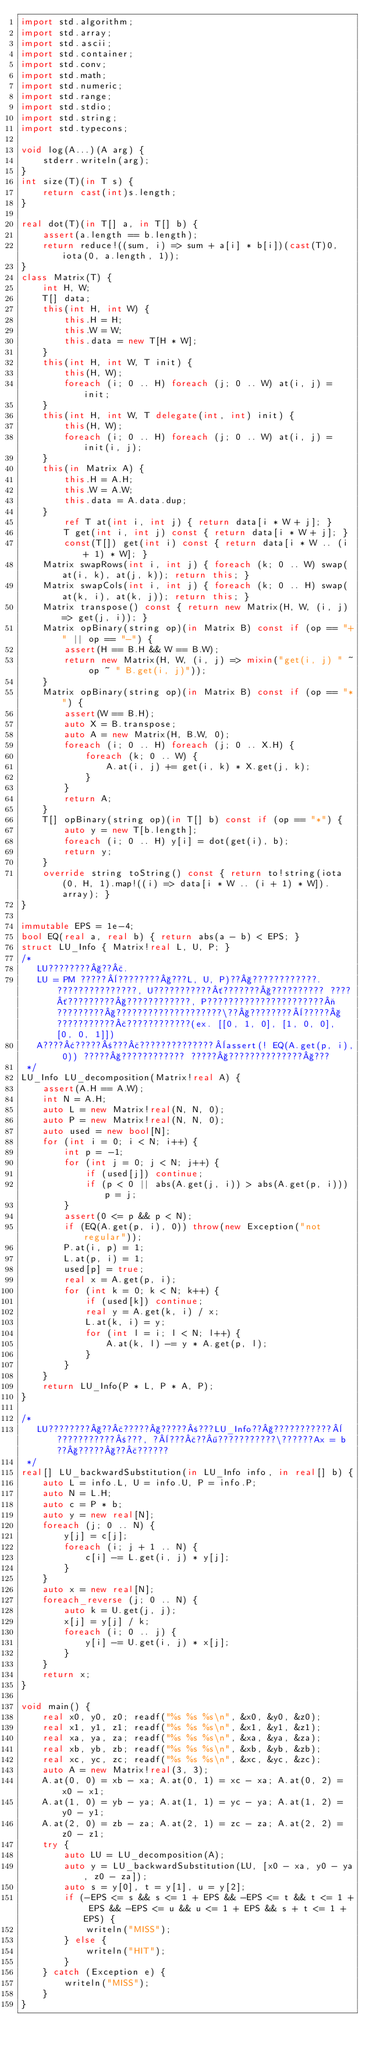<code> <loc_0><loc_0><loc_500><loc_500><_D_>import std.algorithm;
import std.array;
import std.ascii;
import std.container;
import std.conv;
import std.math;
import std.numeric;
import std.range;
import std.stdio;
import std.string;
import std.typecons;

void log(A...)(A arg) {
    stderr.writeln(arg);
}
int size(T)(in T s) {
    return cast(int)s.length;
}

real dot(T)(in T[] a, in T[] b) {
    assert(a.length == b.length);
    return reduce!((sum, i) => sum + a[i] * b[i])(cast(T)0, iota(0, a.length, 1));
}
class Matrix(T) {
    int H, W;
    T[] data;
    this(int H, int W) {
        this.H = H;
        this.W = W;
        this.data = new T[H * W];
    }
    this(int H, int W, T init) {
        this(H, W);
        foreach (i; 0 .. H) foreach (j; 0 .. W) at(i, j) = init;
    }
    this(int H, int W, T delegate(int, int) init) {
        this(H, W);
        foreach (i; 0 .. H) foreach (j; 0 .. W) at(i, j) = init(i, j);
    }
    this(in Matrix A) {
        this.H = A.H;
        this.W = A.W;
        this.data = A.data.dup;
    }
        ref T at(int i, int j) { return data[i * W + j]; }
        T get(int i, int j) const { return data[i * W + j]; }
        const(T[]) get(int i) const { return data[i * W .. (i + 1) * W]; }
    Matrix swapRows(int i, int j) { foreach (k; 0 .. W) swap(at(i, k), at(j, k)); return this; }
    Matrix swapCols(int i, int j) { foreach (k; 0 .. H) swap(at(k, i), at(k, j)); return this; }
    Matrix transpose() const { return new Matrix(H, W, (i, j) => get(j, i)); }
    Matrix opBinary(string op)(in Matrix B) const if (op == "+" || op == "-") {
        assert(H == B.H && W == B.W);
        return new Matrix(H, W, (i, j) => mixin("get(i, j) " ~ op ~ " B.get(i, j)"));
    }
    Matrix opBinary(string op)(in Matrix B) const if (op == "*") {
        assert(W == B.H);
        auto X = B.transpose;
        auto A = new Matrix(H, B.W, 0);
        foreach (i; 0 .. H) foreach (j; 0 .. X.H) {
            foreach (k; 0 .. W) {
                A.at(i, j) += get(i, k) * X.get(j, k);
            }
        }
        return A;
    }
    T[] opBinary(string op)(in T[] b) const if (op == "*") {
        auto y = new T[b.length];
        foreach (i; 0 .. H) y[i] = dot(get(i), b);
        return y;
    }
    override string toString() const { return to!string(iota(0, H, 1).map!((i) => data[i * W .. (i + 1) * W]).array); }
}

immutable EPS = 1e-4;
bool EQ(real a, real b) { return abs(a - b) < EPS; }
struct LU_Info { Matrix!real L, U, P; }
/*
   LU????????§??£.
   LU = PM ?????¨????????§???L, U, P)??§????????????. ???????????????, U???????????´???????§?????????? ????´?????????§????????????, P??????????????????????¬?????????§????????????????????\??§????????¨?????§???????????£????????????(ex. [[0, 1, 0], [1, 0, 0], [0, 0, 1]])
   A????¢?????±???£??????????????¨assert(! EQ(A.get(p, i), 0)) ?????§???????????? ?????§??????????????§???
 */
LU_Info LU_decomposition(Matrix!real A) {
    assert(A.H == A.W);
    int N = A.H;
    auto L = new Matrix!real(N, N, 0);
    auto P = new Matrix!real(N, N, 0);
    auto used = new bool[N];
    for (int i = 0; i < N; i++) {
        int p = -1;
        for (int j = 0; j < N; j++) {
            if (used[j]) continue;
            if (p < 0 || abs(A.get(j, i)) > abs(A.get(p, i))) p = j;
        }
        assert(0 <= p && p < N);
        if (EQ(A.get(p, i), 0)) throw(new Exception("not regular"));
        P.at(i, p) = 1;
        L.at(p, i) = 1;
        used[p] = true;
        real x = A.get(p, i);
        for (int k = 0; k < N; k++) {
            if (used[k]) continue;
            real y = A.get(k, i) / x;
            L.at(k, i) = y;
            for (int l = i; l < N; l++) {
                A.at(k, l) -= y * A.get(p, l);
            }
        }
    }
    return LU_Info(P * L, P * A, P);
}

/*
   LU????????§??£?????§?????±???LU_Info??§???????????¨???????????±???, ?¨???£??¶???????????\??????Ax = b ??§?????§??£??????
 */
real[] LU_backwardSubstitution(in LU_Info info, in real[] b) {
    auto L = info.L, U = info.U, P = info.P;
    auto N = L.H;
    auto c = P * b;
    auto y = new real[N];
    foreach (j; 0 .. N) {
        y[j] = c[j];
        foreach (i; j + 1 .. N) {
            c[i] -= L.get(i, j) * y[j];
        }
    }
    auto x = new real[N];
    foreach_reverse (j; 0 .. N) {
        auto k = U.get(j, j);
        x[j] = y[j] / k;
        foreach (i; 0 .. j) {
            y[i] -= U.get(i, j) * x[j];
        }
    }
    return x;
}

void main() {
    real x0, y0, z0; readf("%s %s %s\n", &x0, &y0, &z0);
    real x1, y1, z1; readf("%s %s %s\n", &x1, &y1, &z1);
    real xa, ya, za; readf("%s %s %s\n", &xa, &ya, &za);
    real xb, yb, zb; readf("%s %s %s\n", &xb, &yb, &zb);
    real xc, yc, zc; readf("%s %s %s\n", &xc, &yc, &zc);
    auto A = new Matrix!real(3, 3);
    A.at(0, 0) = xb - xa; A.at(0, 1) = xc - xa; A.at(0, 2) = x0 - x1;
    A.at(1, 0) = yb - ya; A.at(1, 1) = yc - ya; A.at(1, 2) = y0 - y1;
    A.at(2, 0) = zb - za; A.at(2, 1) = zc - za; A.at(2, 2) = z0 - z1;
    try {
        auto LU = LU_decomposition(A);
        auto y = LU_backwardSubstitution(LU, [x0 - xa, y0 - ya, z0 - za]);
        auto s = y[0], t = y[1], u = y[2];
        if (-EPS <= s && s <= 1 + EPS && -EPS <= t && t <= 1 + EPS && -EPS <= u && u <= 1 + EPS && s + t <= 1 + EPS) {
            writeln("MISS");
        } else {
            writeln("HIT");
        }
    } catch (Exception e) {
        writeln("MISS");
    }
}</code> 